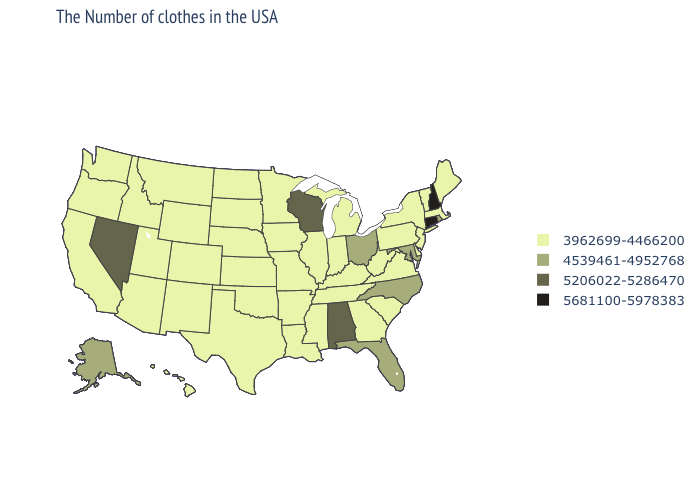What is the highest value in the USA?
Quick response, please. 5681100-5978383. What is the value of North Dakota?
Write a very short answer. 3962699-4466200. What is the lowest value in states that border Nevada?
Write a very short answer. 3962699-4466200. Name the states that have a value in the range 5681100-5978383?
Keep it brief. New Hampshire, Connecticut. What is the lowest value in the USA?
Write a very short answer. 3962699-4466200. What is the value of Michigan?
Be succinct. 3962699-4466200. Does the map have missing data?
Quick response, please. No. Is the legend a continuous bar?
Be succinct. No. Name the states that have a value in the range 5681100-5978383?
Answer briefly. New Hampshire, Connecticut. What is the lowest value in states that border Louisiana?
Write a very short answer. 3962699-4466200. What is the value of Minnesota?
Write a very short answer. 3962699-4466200. What is the value of Hawaii?
Write a very short answer. 3962699-4466200. Name the states that have a value in the range 3962699-4466200?
Give a very brief answer. Maine, Massachusetts, Vermont, New York, New Jersey, Delaware, Pennsylvania, Virginia, South Carolina, West Virginia, Georgia, Michigan, Kentucky, Indiana, Tennessee, Illinois, Mississippi, Louisiana, Missouri, Arkansas, Minnesota, Iowa, Kansas, Nebraska, Oklahoma, Texas, South Dakota, North Dakota, Wyoming, Colorado, New Mexico, Utah, Montana, Arizona, Idaho, California, Washington, Oregon, Hawaii. Among the states that border Massachusetts , does Vermont have the highest value?
Answer briefly. No. Does Minnesota have the highest value in the MidWest?
Give a very brief answer. No. 